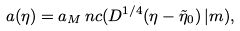Convert formula to latex. <formula><loc_0><loc_0><loc_500><loc_500>a ( \eta ) = a _ { M } \, n c ( D ^ { 1 / 4 } ( \eta - \tilde { \eta } _ { 0 } ) \, | m ) ,</formula> 